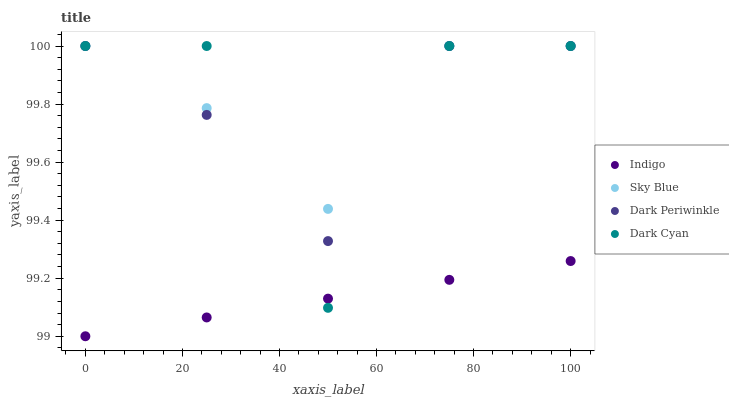Does Indigo have the minimum area under the curve?
Answer yes or no. Yes. Does Sky Blue have the maximum area under the curve?
Answer yes or no. Yes. Does Sky Blue have the minimum area under the curve?
Answer yes or no. No. Does Indigo have the maximum area under the curve?
Answer yes or no. No. Is Indigo the smoothest?
Answer yes or no. Yes. Is Dark Cyan the roughest?
Answer yes or no. Yes. Is Sky Blue the smoothest?
Answer yes or no. No. Is Sky Blue the roughest?
Answer yes or no. No. Does Indigo have the lowest value?
Answer yes or no. Yes. Does Sky Blue have the lowest value?
Answer yes or no. No. Does Dark Periwinkle have the highest value?
Answer yes or no. Yes. Does Indigo have the highest value?
Answer yes or no. No. Is Indigo less than Dark Periwinkle?
Answer yes or no. Yes. Is Dark Periwinkle greater than Indigo?
Answer yes or no. Yes. Does Dark Cyan intersect Dark Periwinkle?
Answer yes or no. Yes. Is Dark Cyan less than Dark Periwinkle?
Answer yes or no. No. Is Dark Cyan greater than Dark Periwinkle?
Answer yes or no. No. Does Indigo intersect Dark Periwinkle?
Answer yes or no. No. 